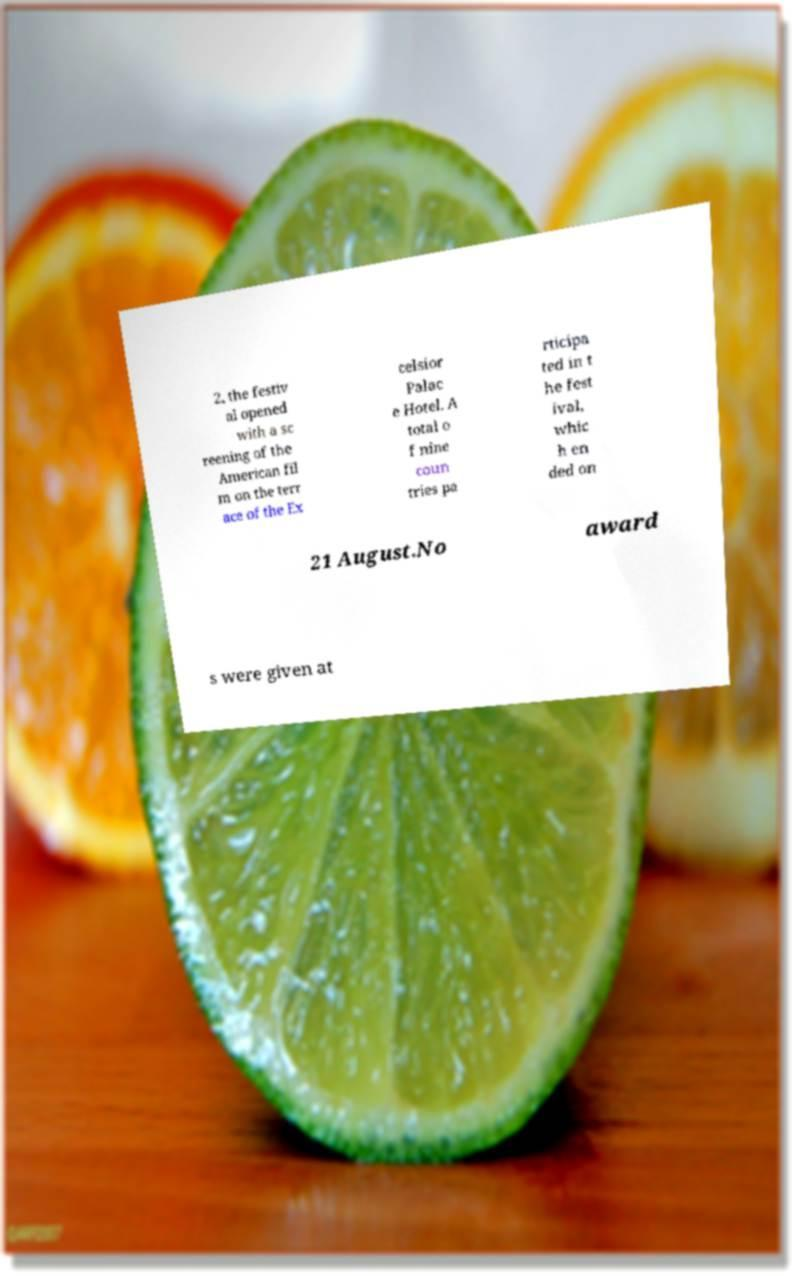Please read and relay the text visible in this image. What does it say? 2, the festiv al opened with a sc reening of the American fil m on the terr ace of the Ex celsior Palac e Hotel. A total o f nine coun tries pa rticipa ted in t he fest ival, whic h en ded on 21 August.No award s were given at 